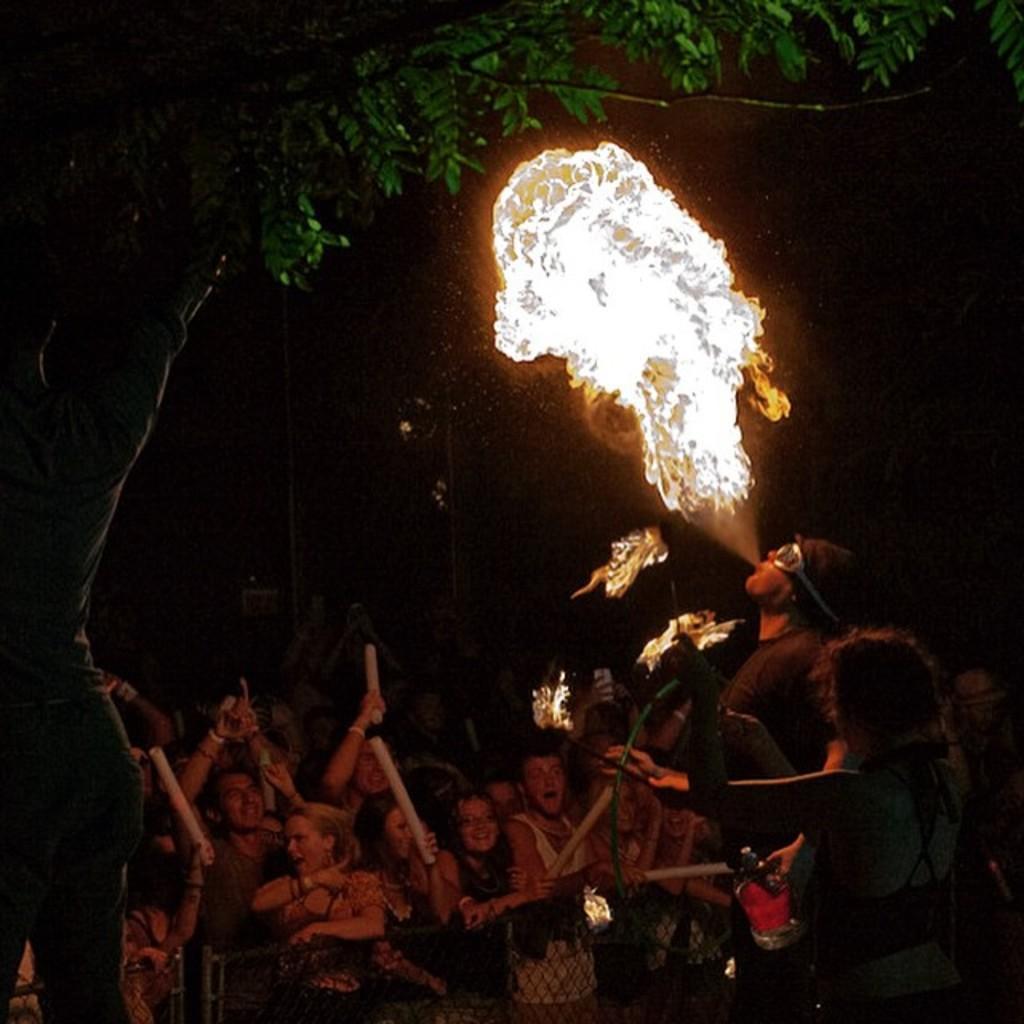Please provide a concise description of this image. In this image there are two people performing an action and behind them there is a group of people standing, a few of them are holding objects and in the background there is a tree. 